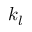Convert formula to latex. <formula><loc_0><loc_0><loc_500><loc_500>k _ { l }</formula> 